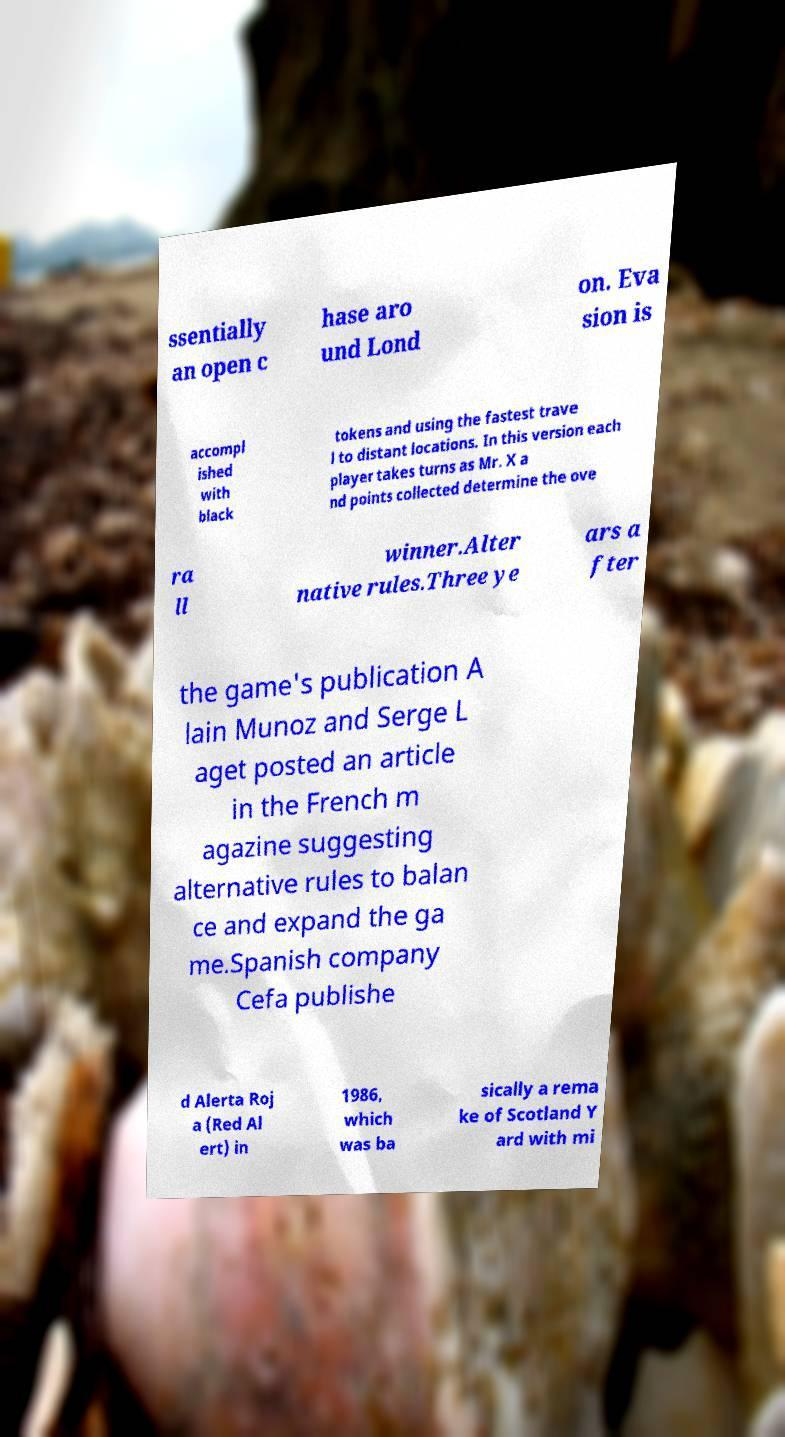I need the written content from this picture converted into text. Can you do that? ssentially an open c hase aro und Lond on. Eva sion is accompl ished with black tokens and using the fastest trave l to distant locations. In this version each player takes turns as Mr. X a nd points collected determine the ove ra ll winner.Alter native rules.Three ye ars a fter the game's publication A lain Munoz and Serge L aget posted an article in the French m agazine suggesting alternative rules to balan ce and expand the ga me.Spanish company Cefa publishe d Alerta Roj a (Red Al ert) in 1986, which was ba sically a rema ke of Scotland Y ard with mi 